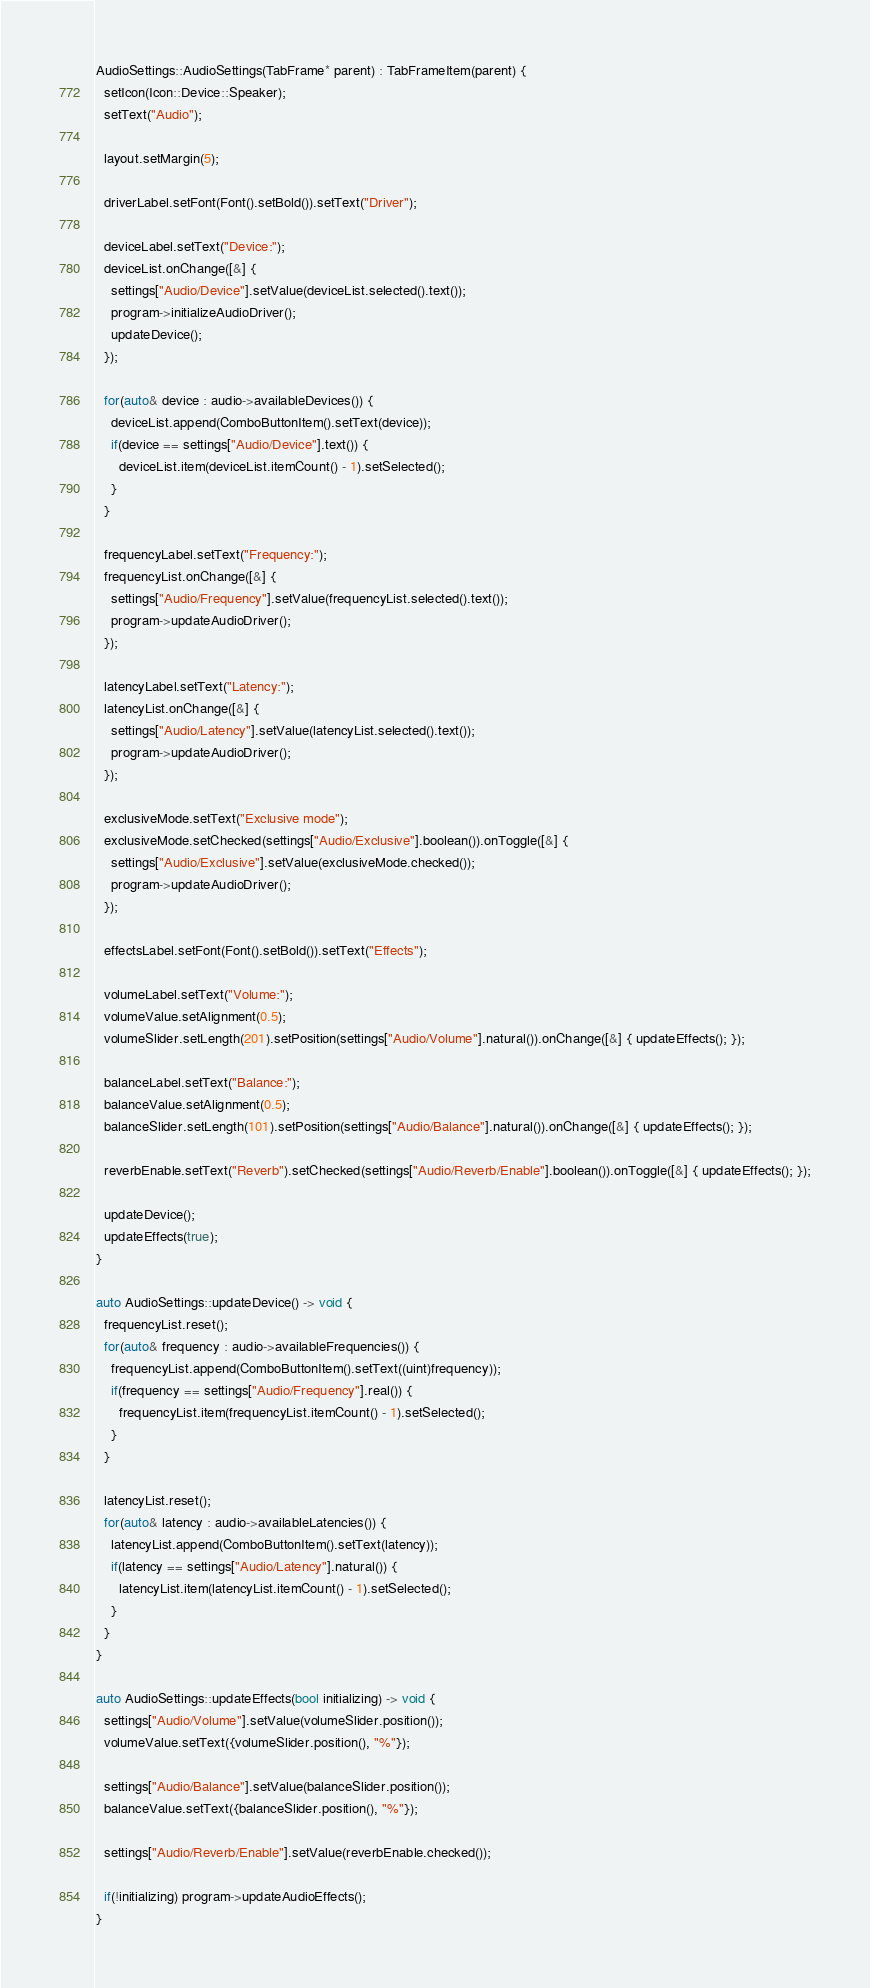<code> <loc_0><loc_0><loc_500><loc_500><_C++_>AudioSettings::AudioSettings(TabFrame* parent) : TabFrameItem(parent) {
  setIcon(Icon::Device::Speaker);
  setText("Audio");

  layout.setMargin(5);

  driverLabel.setFont(Font().setBold()).setText("Driver");

  deviceLabel.setText("Device:");
  deviceList.onChange([&] {
    settings["Audio/Device"].setValue(deviceList.selected().text());
    program->initializeAudioDriver();
    updateDevice();
  });

  for(auto& device : audio->availableDevices()) {
    deviceList.append(ComboButtonItem().setText(device));
    if(device == settings["Audio/Device"].text()) {
      deviceList.item(deviceList.itemCount() - 1).setSelected();
    }
  }

  frequencyLabel.setText("Frequency:");
  frequencyList.onChange([&] {
    settings["Audio/Frequency"].setValue(frequencyList.selected().text());
    program->updateAudioDriver();
  });

  latencyLabel.setText("Latency:");
  latencyList.onChange([&] {
    settings["Audio/Latency"].setValue(latencyList.selected().text());
    program->updateAudioDriver();
  });

  exclusiveMode.setText("Exclusive mode");
  exclusiveMode.setChecked(settings["Audio/Exclusive"].boolean()).onToggle([&] {
    settings["Audio/Exclusive"].setValue(exclusiveMode.checked());
    program->updateAudioDriver();
  });

  effectsLabel.setFont(Font().setBold()).setText("Effects");

  volumeLabel.setText("Volume:");
  volumeValue.setAlignment(0.5);
  volumeSlider.setLength(201).setPosition(settings["Audio/Volume"].natural()).onChange([&] { updateEffects(); });

  balanceLabel.setText("Balance:");
  balanceValue.setAlignment(0.5);
  balanceSlider.setLength(101).setPosition(settings["Audio/Balance"].natural()).onChange([&] { updateEffects(); });

  reverbEnable.setText("Reverb").setChecked(settings["Audio/Reverb/Enable"].boolean()).onToggle([&] { updateEffects(); });

  updateDevice();
  updateEffects(true);
}

auto AudioSettings::updateDevice() -> void {
  frequencyList.reset();
  for(auto& frequency : audio->availableFrequencies()) {
    frequencyList.append(ComboButtonItem().setText((uint)frequency));
    if(frequency == settings["Audio/Frequency"].real()) {
      frequencyList.item(frequencyList.itemCount() - 1).setSelected();
    }
  }

  latencyList.reset();
  for(auto& latency : audio->availableLatencies()) {
    latencyList.append(ComboButtonItem().setText(latency));
    if(latency == settings["Audio/Latency"].natural()) {
      latencyList.item(latencyList.itemCount() - 1).setSelected();
    }
  }
}

auto AudioSettings::updateEffects(bool initializing) -> void {
  settings["Audio/Volume"].setValue(volumeSlider.position());
  volumeValue.setText({volumeSlider.position(), "%"});

  settings["Audio/Balance"].setValue(balanceSlider.position());
  balanceValue.setText({balanceSlider.position(), "%"});

  settings["Audio/Reverb/Enable"].setValue(reverbEnable.checked());

  if(!initializing) program->updateAudioEffects();
}
</code> 